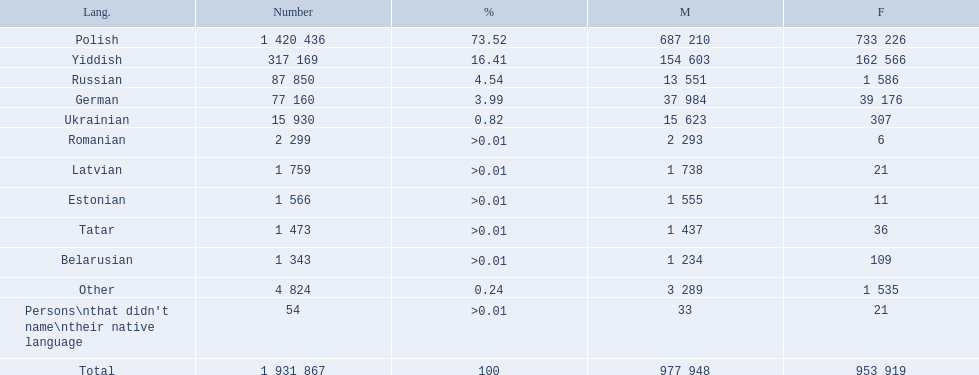What are the languages of the warsaw governorate? Polish, Yiddish, Russian, German, Ukrainian, Romanian, Latvian, Estonian, Tatar, Belarusian, Other. What is the percentage of polish? 73.52. What is the next highest amount? 16.41. What is the language with this amount? Yiddish. 